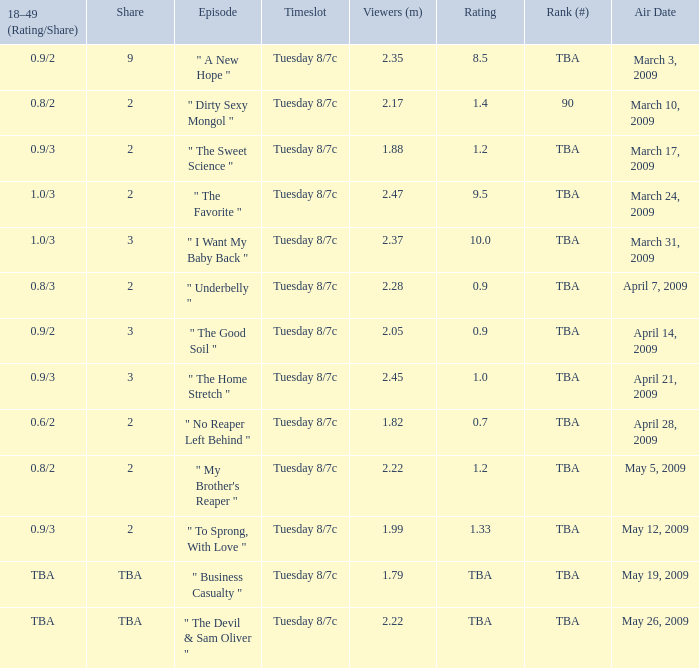What is the rating of the show ranked tba, aired on April 21, 2009? 1.0. 